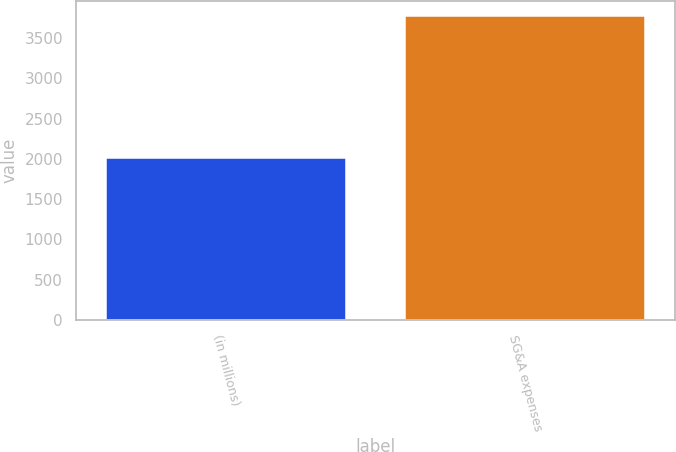<chart> <loc_0><loc_0><loc_500><loc_500><bar_chart><fcel>(in millions)<fcel>SG&A expenses<nl><fcel>2017<fcel>3775<nl></chart> 